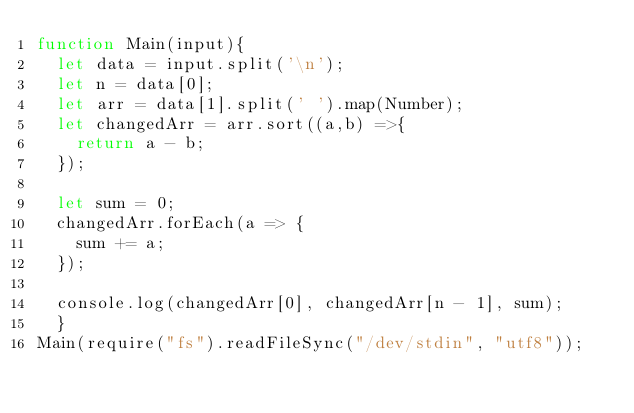<code> <loc_0><loc_0><loc_500><loc_500><_JavaScript_>function Main(input){
  let data = input.split('\n');
  let n = data[0];
  let arr = data[1].split(' ').map(Number);
  let changedArr = arr.sort((a,b) =>{
    return a - b;
  });

  let sum = 0;
  changedArr.forEach(a => {
    sum += a;
  });
  
  console.log(changedArr[0], changedArr[n - 1], sum);
  }
Main(require("fs").readFileSync("/dev/stdin", "utf8"));
</code> 